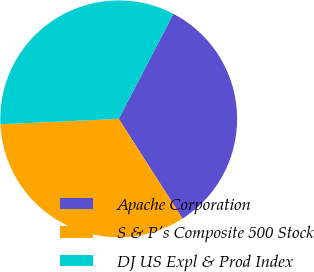<chart> <loc_0><loc_0><loc_500><loc_500><pie_chart><fcel>Apache Corporation<fcel>S & P's Composite 500 Stock<fcel>DJ US Expl & Prod Index<nl><fcel>33.3%<fcel>33.33%<fcel>33.37%<nl></chart> 